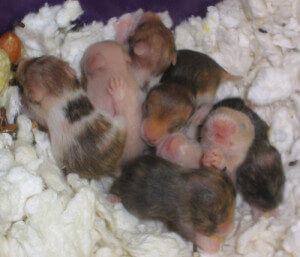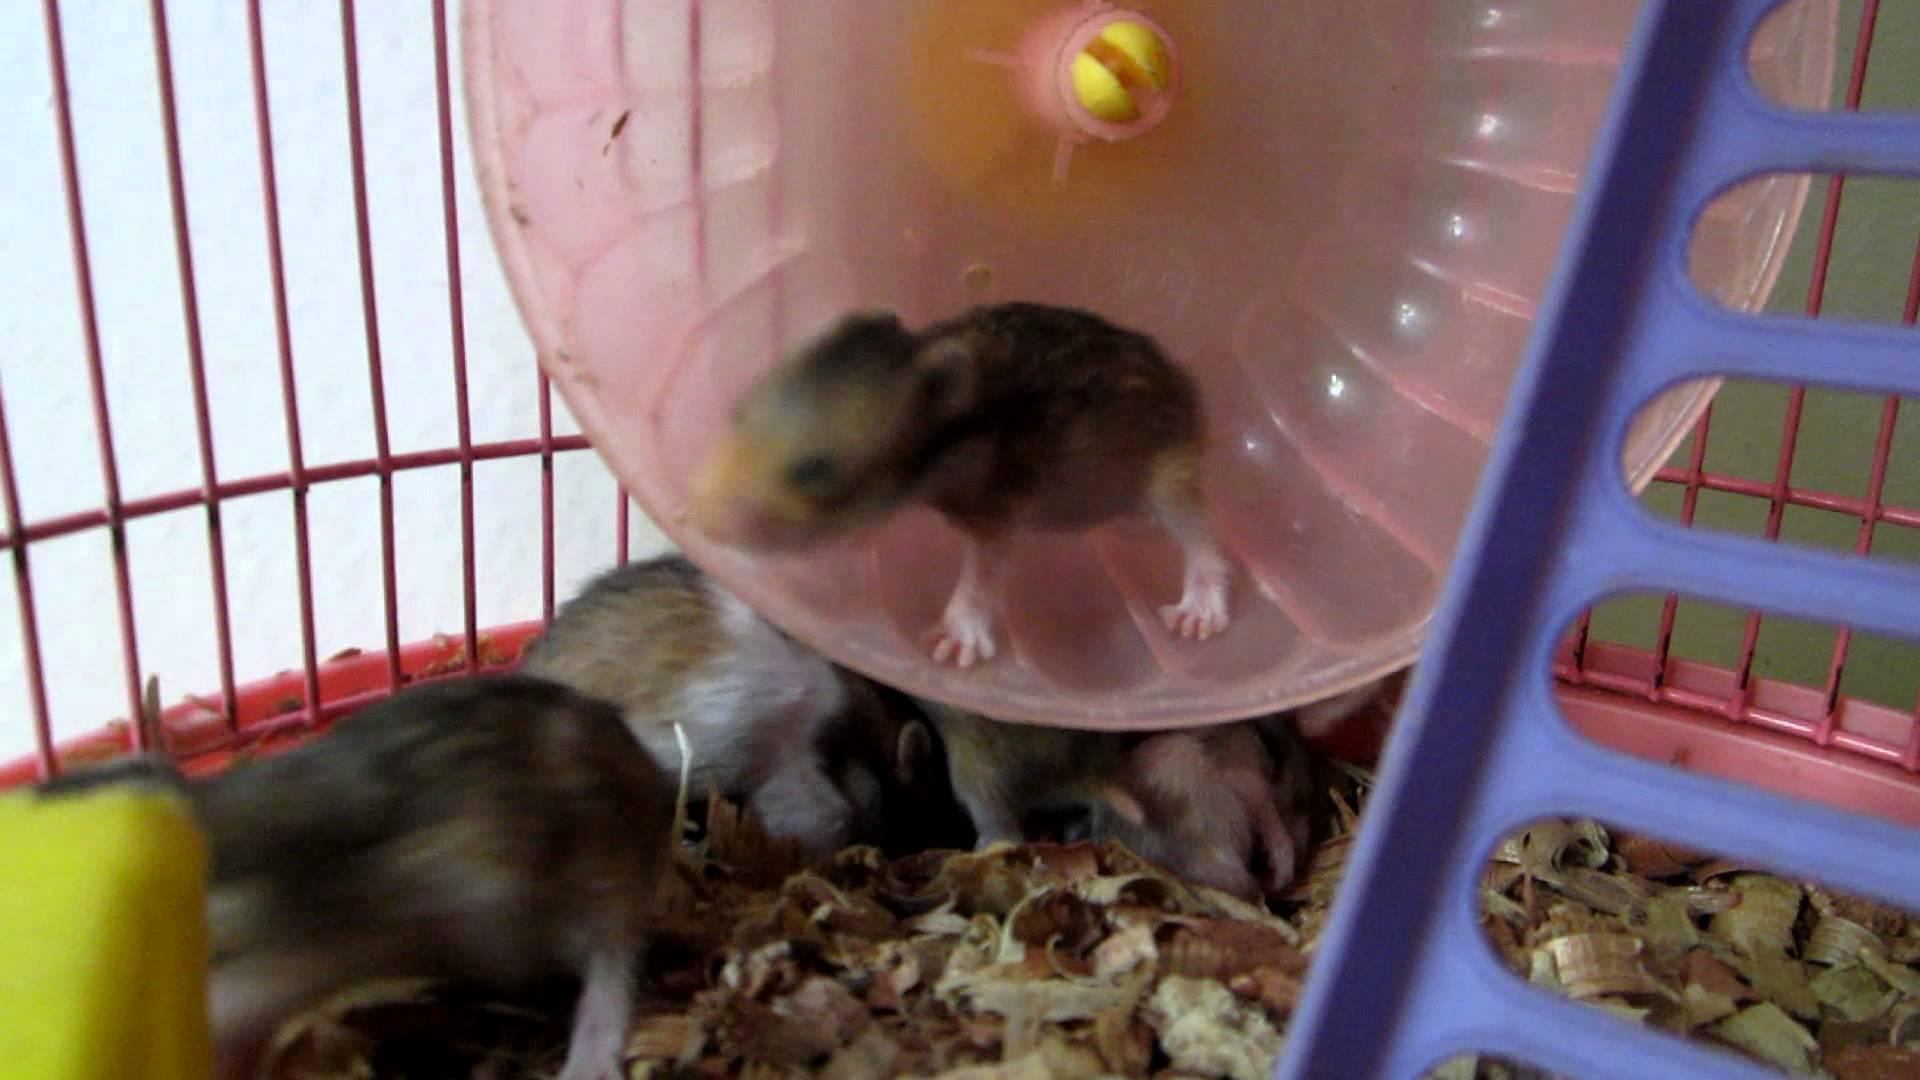The first image is the image on the left, the second image is the image on the right. Evaluate the accuracy of this statement regarding the images: "The left image contains only non-newborn mouse-like pets, and the right image shows all mouse-like pets on shredded bedding.". Is it true? Answer yes or no. No. The first image is the image on the left, the second image is the image on the right. For the images shown, is this caption "There are more hamsters in the right image than in the left image." true? Answer yes or no. No. 